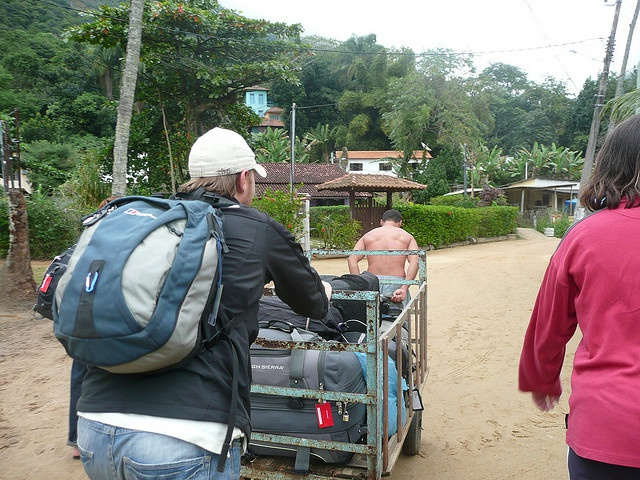Describe the objects in this image and their specific colors. I can see people in darkgreen, black, gray, white, and blue tones, people in darkgreen, brown, salmon, and maroon tones, backpack in darkgreen, gray, blue, black, and lightgray tones, suitcase in darkgreen, gray, black, darkgray, and purple tones, and people in darkgreen, lightpink, lightgray, gray, and pink tones in this image. 